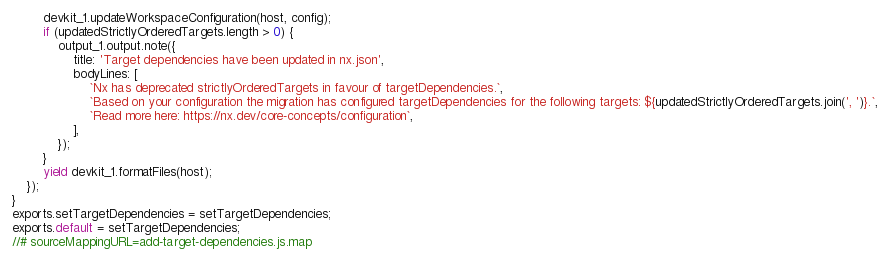<code> <loc_0><loc_0><loc_500><loc_500><_JavaScript_>        devkit_1.updateWorkspaceConfiguration(host, config);
        if (updatedStrictlyOrderedTargets.length > 0) {
            output_1.output.note({
                title: 'Target dependencies have been updated in nx.json',
                bodyLines: [
                    `Nx has deprecated strictlyOrderedTargets in favour of targetDependencies.`,
                    `Based on your configuration the migration has configured targetDependencies for the following targets: ${updatedStrictlyOrderedTargets.join(', ')}.`,
                    `Read more here: https://nx.dev/core-concepts/configuration`,
                ],
            });
        }
        yield devkit_1.formatFiles(host);
    });
}
exports.setTargetDependencies = setTargetDependencies;
exports.default = setTargetDependencies;
//# sourceMappingURL=add-target-dependencies.js.map</code> 